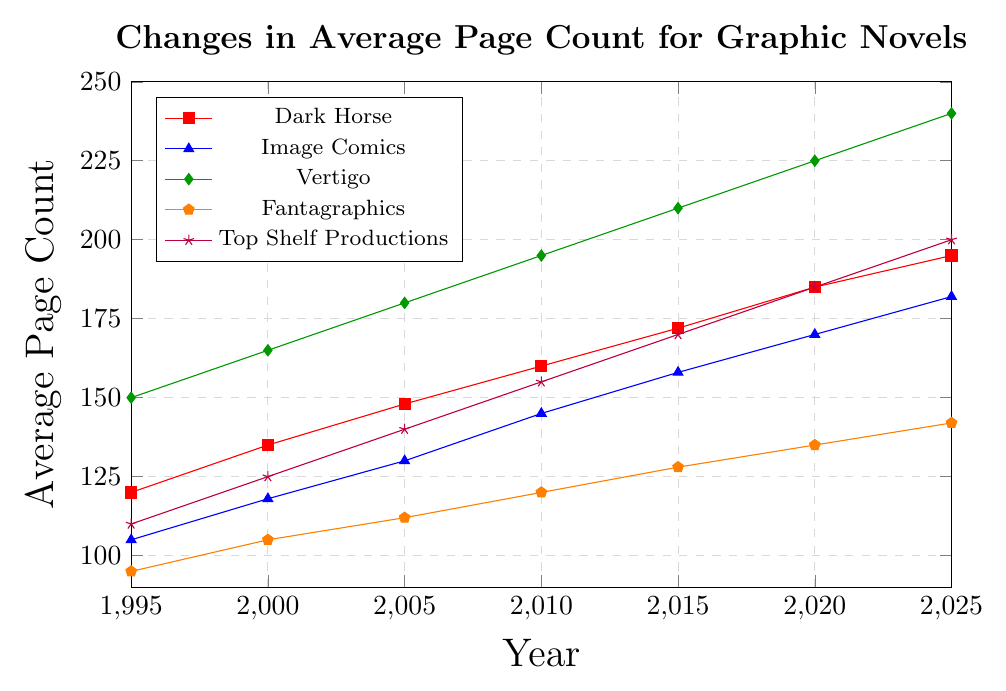Which publisher had the highest average page count in 2020? From the chart, the line representing Vertigo reaches the highest point in 2020 compared to other publishers.
Answer: Vertigo How much did the average page count for Dark Horse increase from 1995 to 2025? The average page count for Dark Horse in 1995 was 120, and in 2025 it was 195. The difference is 195 - 120.
Answer: 75 Which publisher had the lowest average page count in 1995? The chart shows that Fantagraphics has the lowest starting point in 1995 compared to the other publishers.
Answer: Fantagraphics What is the total increase in average page count for Image Comics and Top Shelf Productions from 1995 to 2020? Image Comics increased from 105 to 170 and Top Shelf Productions increased from 110 to 185. The total increase is (170 - 105) + (185 - 110).
Answer: 140 Between which two consecutive years did Vertigo see the largest increase in average page count? Vertigo shows the largest increase between 2020 (225) and 2025 (240), which is an increase of 15.
Answer: 2020 and 2025 What is the average page count growth per year for Fantagraphics from 1995 to 2025? Fantagraphics started in 1995 with 95 and ended in 2025 with 142. The time span is 30 years. The growth per year is (142 - 95) / 30.
Answer: 1.57 Which publisher had the highest average page count growth rate, and what was that rate? Calculate the initial and final values for each publisher over 30 years, then find the highest rate. Vertigo's growth from 150 to 240 is the highest: (240 - 150) / 30.
Answer: Vertigo, 3 How do the trends of average page counts of Image Comics and Dark Horse compare visually? Both lines rise steadily over time, with Image Comics consistently lower but with a similar upward trend to Dark Horse.
Answer: Similar upward trend but lower levels In what year did Top Shelf Productions surpass an average page count of 160? The chart shows Top Shelf Productions surpassed an average of 160 pages between 2010 (155) and 2015 (170).
Answer: 2015 How many years did it take for Dark Horse to reach an average page count of 160? Dark Horse reached 160 pages in 2010, starting from 120 in 1995, taking 15 years.
Answer: 15 